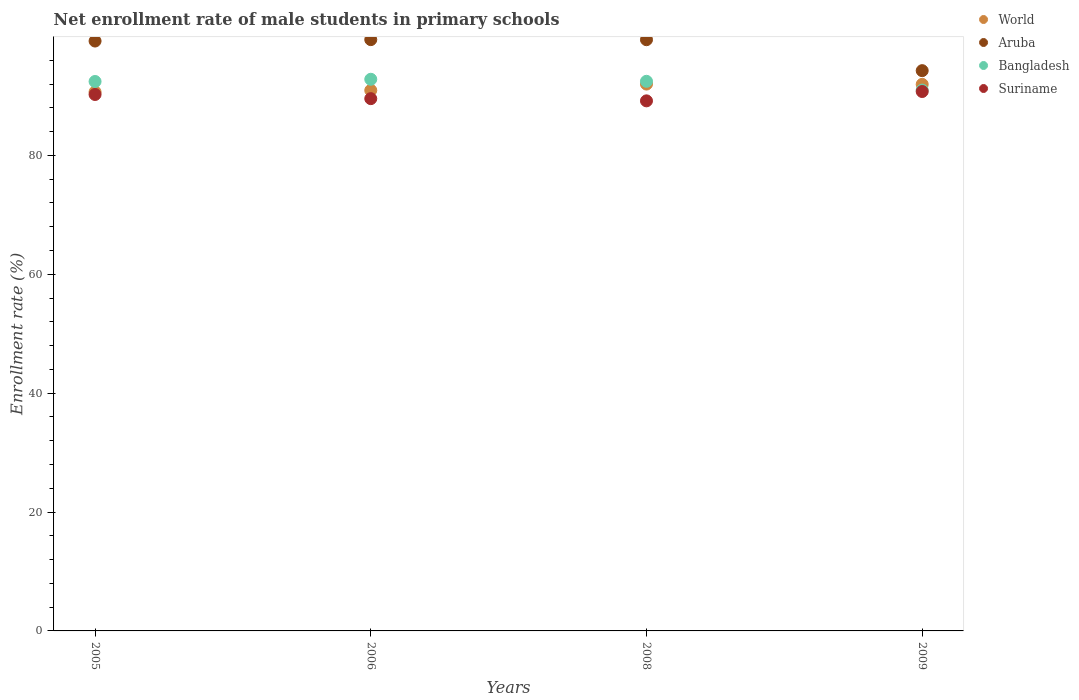How many different coloured dotlines are there?
Your answer should be very brief. 4. What is the net enrollment rate of male students in primary schools in World in 2006?
Make the answer very short. 90.94. Across all years, what is the maximum net enrollment rate of male students in primary schools in World?
Make the answer very short. 92. Across all years, what is the minimum net enrollment rate of male students in primary schools in World?
Your answer should be compact. 90.67. In which year was the net enrollment rate of male students in primary schools in Bangladesh maximum?
Give a very brief answer. 2006. In which year was the net enrollment rate of male students in primary schools in Aruba minimum?
Keep it short and to the point. 2009. What is the total net enrollment rate of male students in primary schools in Suriname in the graph?
Provide a short and direct response. 359.72. What is the difference between the net enrollment rate of male students in primary schools in World in 2006 and that in 2009?
Your answer should be compact. -1.01. What is the difference between the net enrollment rate of male students in primary schools in World in 2008 and the net enrollment rate of male students in primary schools in Aruba in 2009?
Provide a short and direct response. -2.26. What is the average net enrollment rate of male students in primary schools in World per year?
Give a very brief answer. 91.39. In the year 2006, what is the difference between the net enrollment rate of male students in primary schools in Aruba and net enrollment rate of male students in primary schools in Suriname?
Provide a short and direct response. 9.93. In how many years, is the net enrollment rate of male students in primary schools in Suriname greater than 84 %?
Keep it short and to the point. 4. What is the ratio of the net enrollment rate of male students in primary schools in Aruba in 2006 to that in 2008?
Offer a terse response. 1. Is the net enrollment rate of male students in primary schools in Aruba in 2005 less than that in 2008?
Your answer should be very brief. Yes. Is the difference between the net enrollment rate of male students in primary schools in Aruba in 2005 and 2009 greater than the difference between the net enrollment rate of male students in primary schools in Suriname in 2005 and 2009?
Keep it short and to the point. Yes. What is the difference between the highest and the second highest net enrollment rate of male students in primary schools in Aruba?
Provide a succinct answer. 0.01. What is the difference between the highest and the lowest net enrollment rate of male students in primary schools in Suriname?
Offer a terse response. 1.57. Is the sum of the net enrollment rate of male students in primary schools in Suriname in 2005 and 2009 greater than the maximum net enrollment rate of male students in primary schools in World across all years?
Your response must be concise. Yes. Is it the case that in every year, the sum of the net enrollment rate of male students in primary schools in Suriname and net enrollment rate of male students in primary schools in Aruba  is greater than the net enrollment rate of male students in primary schools in Bangladesh?
Keep it short and to the point. Yes. Is the net enrollment rate of male students in primary schools in Aruba strictly greater than the net enrollment rate of male students in primary schools in Bangladesh over the years?
Provide a succinct answer. Yes. Does the graph contain any zero values?
Your answer should be compact. No. How many legend labels are there?
Make the answer very short. 4. What is the title of the graph?
Provide a short and direct response. Net enrollment rate of male students in primary schools. What is the label or title of the Y-axis?
Give a very brief answer. Enrollment rate (%). What is the Enrollment rate (%) in World in 2005?
Your answer should be compact. 90.67. What is the Enrollment rate (%) in Aruba in 2005?
Ensure brevity in your answer.  99.24. What is the Enrollment rate (%) of Bangladesh in 2005?
Provide a succinct answer. 92.44. What is the Enrollment rate (%) in Suriname in 2005?
Give a very brief answer. 90.25. What is the Enrollment rate (%) in World in 2006?
Ensure brevity in your answer.  90.94. What is the Enrollment rate (%) in Aruba in 2006?
Keep it short and to the point. 99.48. What is the Enrollment rate (%) in Bangladesh in 2006?
Ensure brevity in your answer.  92.81. What is the Enrollment rate (%) of Suriname in 2006?
Provide a succinct answer. 89.55. What is the Enrollment rate (%) of World in 2008?
Provide a succinct answer. 92. What is the Enrollment rate (%) of Aruba in 2008?
Your response must be concise. 99.46. What is the Enrollment rate (%) in Bangladesh in 2008?
Provide a short and direct response. 92.47. What is the Enrollment rate (%) in Suriname in 2008?
Give a very brief answer. 89.18. What is the Enrollment rate (%) of World in 2009?
Offer a terse response. 91.95. What is the Enrollment rate (%) in Aruba in 2009?
Your answer should be very brief. 94.26. What is the Enrollment rate (%) of Bangladesh in 2009?
Your response must be concise. 90.99. What is the Enrollment rate (%) in Suriname in 2009?
Provide a short and direct response. 90.75. Across all years, what is the maximum Enrollment rate (%) of World?
Offer a terse response. 92. Across all years, what is the maximum Enrollment rate (%) in Aruba?
Keep it short and to the point. 99.48. Across all years, what is the maximum Enrollment rate (%) of Bangladesh?
Ensure brevity in your answer.  92.81. Across all years, what is the maximum Enrollment rate (%) in Suriname?
Offer a terse response. 90.75. Across all years, what is the minimum Enrollment rate (%) of World?
Keep it short and to the point. 90.67. Across all years, what is the minimum Enrollment rate (%) in Aruba?
Keep it short and to the point. 94.26. Across all years, what is the minimum Enrollment rate (%) in Bangladesh?
Offer a terse response. 90.99. Across all years, what is the minimum Enrollment rate (%) in Suriname?
Ensure brevity in your answer.  89.18. What is the total Enrollment rate (%) of World in the graph?
Your answer should be compact. 365.57. What is the total Enrollment rate (%) of Aruba in the graph?
Your answer should be very brief. 392.44. What is the total Enrollment rate (%) in Bangladesh in the graph?
Offer a terse response. 368.7. What is the total Enrollment rate (%) in Suriname in the graph?
Give a very brief answer. 359.72. What is the difference between the Enrollment rate (%) of World in 2005 and that in 2006?
Give a very brief answer. -0.27. What is the difference between the Enrollment rate (%) of Aruba in 2005 and that in 2006?
Your answer should be compact. -0.24. What is the difference between the Enrollment rate (%) in Bangladesh in 2005 and that in 2006?
Keep it short and to the point. -0.37. What is the difference between the Enrollment rate (%) of Suriname in 2005 and that in 2006?
Offer a terse response. 0.7. What is the difference between the Enrollment rate (%) of World in 2005 and that in 2008?
Provide a short and direct response. -1.33. What is the difference between the Enrollment rate (%) in Aruba in 2005 and that in 2008?
Offer a terse response. -0.22. What is the difference between the Enrollment rate (%) in Bangladesh in 2005 and that in 2008?
Provide a succinct answer. -0.03. What is the difference between the Enrollment rate (%) of Suriname in 2005 and that in 2008?
Offer a very short reply. 1.07. What is the difference between the Enrollment rate (%) in World in 2005 and that in 2009?
Provide a succinct answer. -1.28. What is the difference between the Enrollment rate (%) in Aruba in 2005 and that in 2009?
Keep it short and to the point. 4.98. What is the difference between the Enrollment rate (%) of Bangladesh in 2005 and that in 2009?
Keep it short and to the point. 1.45. What is the difference between the Enrollment rate (%) in Suriname in 2005 and that in 2009?
Give a very brief answer. -0.5. What is the difference between the Enrollment rate (%) in World in 2006 and that in 2008?
Ensure brevity in your answer.  -1.06. What is the difference between the Enrollment rate (%) in Aruba in 2006 and that in 2008?
Make the answer very short. 0.01. What is the difference between the Enrollment rate (%) of Bangladesh in 2006 and that in 2008?
Provide a short and direct response. 0.34. What is the difference between the Enrollment rate (%) of Suriname in 2006 and that in 2008?
Your response must be concise. 0.37. What is the difference between the Enrollment rate (%) in World in 2006 and that in 2009?
Give a very brief answer. -1.01. What is the difference between the Enrollment rate (%) of Aruba in 2006 and that in 2009?
Give a very brief answer. 5.22. What is the difference between the Enrollment rate (%) of Bangladesh in 2006 and that in 2009?
Your response must be concise. 1.82. What is the difference between the Enrollment rate (%) of Suriname in 2006 and that in 2009?
Your answer should be compact. -1.2. What is the difference between the Enrollment rate (%) in World in 2008 and that in 2009?
Your answer should be compact. 0.05. What is the difference between the Enrollment rate (%) of Aruba in 2008 and that in 2009?
Offer a very short reply. 5.21. What is the difference between the Enrollment rate (%) of Bangladesh in 2008 and that in 2009?
Make the answer very short. 1.48. What is the difference between the Enrollment rate (%) in Suriname in 2008 and that in 2009?
Your response must be concise. -1.57. What is the difference between the Enrollment rate (%) in World in 2005 and the Enrollment rate (%) in Aruba in 2006?
Your response must be concise. -8.81. What is the difference between the Enrollment rate (%) of World in 2005 and the Enrollment rate (%) of Bangladesh in 2006?
Provide a short and direct response. -2.14. What is the difference between the Enrollment rate (%) of World in 2005 and the Enrollment rate (%) of Suriname in 2006?
Your answer should be compact. 1.12. What is the difference between the Enrollment rate (%) of Aruba in 2005 and the Enrollment rate (%) of Bangladesh in 2006?
Offer a terse response. 6.43. What is the difference between the Enrollment rate (%) in Aruba in 2005 and the Enrollment rate (%) in Suriname in 2006?
Provide a short and direct response. 9.69. What is the difference between the Enrollment rate (%) in Bangladesh in 2005 and the Enrollment rate (%) in Suriname in 2006?
Ensure brevity in your answer.  2.89. What is the difference between the Enrollment rate (%) of World in 2005 and the Enrollment rate (%) of Aruba in 2008?
Your response must be concise. -8.79. What is the difference between the Enrollment rate (%) in World in 2005 and the Enrollment rate (%) in Bangladesh in 2008?
Your answer should be very brief. -1.8. What is the difference between the Enrollment rate (%) in World in 2005 and the Enrollment rate (%) in Suriname in 2008?
Offer a terse response. 1.49. What is the difference between the Enrollment rate (%) of Aruba in 2005 and the Enrollment rate (%) of Bangladesh in 2008?
Offer a terse response. 6.77. What is the difference between the Enrollment rate (%) in Aruba in 2005 and the Enrollment rate (%) in Suriname in 2008?
Offer a very short reply. 10.06. What is the difference between the Enrollment rate (%) of Bangladesh in 2005 and the Enrollment rate (%) of Suriname in 2008?
Your response must be concise. 3.26. What is the difference between the Enrollment rate (%) of World in 2005 and the Enrollment rate (%) of Aruba in 2009?
Ensure brevity in your answer.  -3.59. What is the difference between the Enrollment rate (%) in World in 2005 and the Enrollment rate (%) in Bangladesh in 2009?
Your answer should be very brief. -0.32. What is the difference between the Enrollment rate (%) of World in 2005 and the Enrollment rate (%) of Suriname in 2009?
Provide a short and direct response. -0.08. What is the difference between the Enrollment rate (%) in Aruba in 2005 and the Enrollment rate (%) in Bangladesh in 2009?
Your response must be concise. 8.25. What is the difference between the Enrollment rate (%) of Aruba in 2005 and the Enrollment rate (%) of Suriname in 2009?
Provide a short and direct response. 8.49. What is the difference between the Enrollment rate (%) in Bangladesh in 2005 and the Enrollment rate (%) in Suriname in 2009?
Offer a very short reply. 1.69. What is the difference between the Enrollment rate (%) in World in 2006 and the Enrollment rate (%) in Aruba in 2008?
Your response must be concise. -8.52. What is the difference between the Enrollment rate (%) of World in 2006 and the Enrollment rate (%) of Bangladesh in 2008?
Offer a terse response. -1.52. What is the difference between the Enrollment rate (%) in World in 2006 and the Enrollment rate (%) in Suriname in 2008?
Give a very brief answer. 1.77. What is the difference between the Enrollment rate (%) of Aruba in 2006 and the Enrollment rate (%) of Bangladesh in 2008?
Offer a very short reply. 7.01. What is the difference between the Enrollment rate (%) of Aruba in 2006 and the Enrollment rate (%) of Suriname in 2008?
Ensure brevity in your answer.  10.3. What is the difference between the Enrollment rate (%) in Bangladesh in 2006 and the Enrollment rate (%) in Suriname in 2008?
Your answer should be very brief. 3.63. What is the difference between the Enrollment rate (%) of World in 2006 and the Enrollment rate (%) of Aruba in 2009?
Your answer should be compact. -3.31. What is the difference between the Enrollment rate (%) in World in 2006 and the Enrollment rate (%) in Bangladesh in 2009?
Keep it short and to the point. -0.04. What is the difference between the Enrollment rate (%) of World in 2006 and the Enrollment rate (%) of Suriname in 2009?
Offer a terse response. 0.19. What is the difference between the Enrollment rate (%) of Aruba in 2006 and the Enrollment rate (%) of Bangladesh in 2009?
Your answer should be compact. 8.49. What is the difference between the Enrollment rate (%) of Aruba in 2006 and the Enrollment rate (%) of Suriname in 2009?
Provide a short and direct response. 8.73. What is the difference between the Enrollment rate (%) of Bangladesh in 2006 and the Enrollment rate (%) of Suriname in 2009?
Make the answer very short. 2.06. What is the difference between the Enrollment rate (%) of World in 2008 and the Enrollment rate (%) of Aruba in 2009?
Your answer should be compact. -2.26. What is the difference between the Enrollment rate (%) of World in 2008 and the Enrollment rate (%) of Bangladesh in 2009?
Make the answer very short. 1.01. What is the difference between the Enrollment rate (%) in World in 2008 and the Enrollment rate (%) in Suriname in 2009?
Give a very brief answer. 1.25. What is the difference between the Enrollment rate (%) of Aruba in 2008 and the Enrollment rate (%) of Bangladesh in 2009?
Ensure brevity in your answer.  8.48. What is the difference between the Enrollment rate (%) of Aruba in 2008 and the Enrollment rate (%) of Suriname in 2009?
Provide a succinct answer. 8.72. What is the difference between the Enrollment rate (%) in Bangladesh in 2008 and the Enrollment rate (%) in Suriname in 2009?
Offer a terse response. 1.72. What is the average Enrollment rate (%) in World per year?
Offer a very short reply. 91.39. What is the average Enrollment rate (%) in Aruba per year?
Ensure brevity in your answer.  98.11. What is the average Enrollment rate (%) of Bangladesh per year?
Offer a very short reply. 92.18. What is the average Enrollment rate (%) in Suriname per year?
Offer a terse response. 89.93. In the year 2005, what is the difference between the Enrollment rate (%) in World and Enrollment rate (%) in Aruba?
Your answer should be very brief. -8.57. In the year 2005, what is the difference between the Enrollment rate (%) of World and Enrollment rate (%) of Bangladesh?
Offer a very short reply. -1.76. In the year 2005, what is the difference between the Enrollment rate (%) of World and Enrollment rate (%) of Suriname?
Provide a short and direct response. 0.42. In the year 2005, what is the difference between the Enrollment rate (%) of Aruba and Enrollment rate (%) of Bangladesh?
Make the answer very short. 6.8. In the year 2005, what is the difference between the Enrollment rate (%) of Aruba and Enrollment rate (%) of Suriname?
Your response must be concise. 8.99. In the year 2005, what is the difference between the Enrollment rate (%) of Bangladesh and Enrollment rate (%) of Suriname?
Your answer should be very brief. 2.19. In the year 2006, what is the difference between the Enrollment rate (%) in World and Enrollment rate (%) in Aruba?
Make the answer very short. -8.53. In the year 2006, what is the difference between the Enrollment rate (%) in World and Enrollment rate (%) in Bangladesh?
Provide a succinct answer. -1.86. In the year 2006, what is the difference between the Enrollment rate (%) in World and Enrollment rate (%) in Suriname?
Your response must be concise. 1.39. In the year 2006, what is the difference between the Enrollment rate (%) in Aruba and Enrollment rate (%) in Bangladesh?
Ensure brevity in your answer.  6.67. In the year 2006, what is the difference between the Enrollment rate (%) of Aruba and Enrollment rate (%) of Suriname?
Keep it short and to the point. 9.93. In the year 2006, what is the difference between the Enrollment rate (%) of Bangladesh and Enrollment rate (%) of Suriname?
Give a very brief answer. 3.26. In the year 2008, what is the difference between the Enrollment rate (%) in World and Enrollment rate (%) in Aruba?
Provide a succinct answer. -7.46. In the year 2008, what is the difference between the Enrollment rate (%) in World and Enrollment rate (%) in Bangladesh?
Offer a terse response. -0.47. In the year 2008, what is the difference between the Enrollment rate (%) in World and Enrollment rate (%) in Suriname?
Your answer should be compact. 2.82. In the year 2008, what is the difference between the Enrollment rate (%) in Aruba and Enrollment rate (%) in Bangladesh?
Ensure brevity in your answer.  7. In the year 2008, what is the difference between the Enrollment rate (%) of Aruba and Enrollment rate (%) of Suriname?
Give a very brief answer. 10.29. In the year 2008, what is the difference between the Enrollment rate (%) in Bangladesh and Enrollment rate (%) in Suriname?
Offer a very short reply. 3.29. In the year 2009, what is the difference between the Enrollment rate (%) in World and Enrollment rate (%) in Aruba?
Offer a very short reply. -2.3. In the year 2009, what is the difference between the Enrollment rate (%) of World and Enrollment rate (%) of Bangladesh?
Provide a short and direct response. 0.97. In the year 2009, what is the difference between the Enrollment rate (%) of World and Enrollment rate (%) of Suriname?
Your answer should be very brief. 1.21. In the year 2009, what is the difference between the Enrollment rate (%) in Aruba and Enrollment rate (%) in Bangladesh?
Offer a very short reply. 3.27. In the year 2009, what is the difference between the Enrollment rate (%) in Aruba and Enrollment rate (%) in Suriname?
Give a very brief answer. 3.51. In the year 2009, what is the difference between the Enrollment rate (%) in Bangladesh and Enrollment rate (%) in Suriname?
Offer a terse response. 0.24. What is the ratio of the Enrollment rate (%) of World in 2005 to that in 2006?
Provide a short and direct response. 1. What is the ratio of the Enrollment rate (%) in Suriname in 2005 to that in 2006?
Keep it short and to the point. 1.01. What is the ratio of the Enrollment rate (%) in World in 2005 to that in 2008?
Offer a terse response. 0.99. What is the ratio of the Enrollment rate (%) in Aruba in 2005 to that in 2008?
Keep it short and to the point. 1. What is the ratio of the Enrollment rate (%) of Bangladesh in 2005 to that in 2008?
Provide a short and direct response. 1. What is the ratio of the Enrollment rate (%) of Suriname in 2005 to that in 2008?
Provide a short and direct response. 1.01. What is the ratio of the Enrollment rate (%) of Aruba in 2005 to that in 2009?
Provide a succinct answer. 1.05. What is the ratio of the Enrollment rate (%) of Bangladesh in 2005 to that in 2009?
Provide a succinct answer. 1.02. What is the ratio of the Enrollment rate (%) of Suriname in 2005 to that in 2009?
Offer a very short reply. 0.99. What is the ratio of the Enrollment rate (%) of Suriname in 2006 to that in 2008?
Ensure brevity in your answer.  1. What is the ratio of the Enrollment rate (%) in World in 2006 to that in 2009?
Provide a short and direct response. 0.99. What is the ratio of the Enrollment rate (%) of Aruba in 2006 to that in 2009?
Ensure brevity in your answer.  1.06. What is the ratio of the Enrollment rate (%) of Bangladesh in 2006 to that in 2009?
Provide a succinct answer. 1.02. What is the ratio of the Enrollment rate (%) in World in 2008 to that in 2009?
Your response must be concise. 1. What is the ratio of the Enrollment rate (%) in Aruba in 2008 to that in 2009?
Keep it short and to the point. 1.06. What is the ratio of the Enrollment rate (%) of Bangladesh in 2008 to that in 2009?
Your response must be concise. 1.02. What is the ratio of the Enrollment rate (%) of Suriname in 2008 to that in 2009?
Give a very brief answer. 0.98. What is the difference between the highest and the second highest Enrollment rate (%) of World?
Provide a succinct answer. 0.05. What is the difference between the highest and the second highest Enrollment rate (%) in Aruba?
Provide a short and direct response. 0.01. What is the difference between the highest and the second highest Enrollment rate (%) in Bangladesh?
Give a very brief answer. 0.34. What is the difference between the highest and the second highest Enrollment rate (%) in Suriname?
Make the answer very short. 0.5. What is the difference between the highest and the lowest Enrollment rate (%) in World?
Your answer should be very brief. 1.33. What is the difference between the highest and the lowest Enrollment rate (%) in Aruba?
Offer a very short reply. 5.22. What is the difference between the highest and the lowest Enrollment rate (%) in Bangladesh?
Offer a terse response. 1.82. What is the difference between the highest and the lowest Enrollment rate (%) in Suriname?
Make the answer very short. 1.57. 